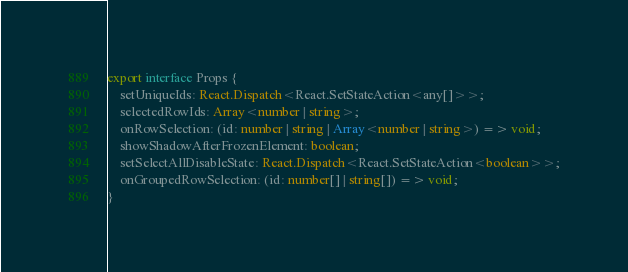<code> <loc_0><loc_0><loc_500><loc_500><_TypeScript_>export interface Props {
    setUniqueIds: React.Dispatch<React.SetStateAction<any[]>>;
    selectedRowIds: Array<number | string>;
    onRowSelection: (id: number | string | Array<number | string>) => void;
    showShadowAfterFrozenElement: boolean;
    setSelectAllDisableState: React.Dispatch<React.SetStateAction<boolean>>;
    onGroupedRowSelection: (id: number[] | string[]) => void;
}
</code> 